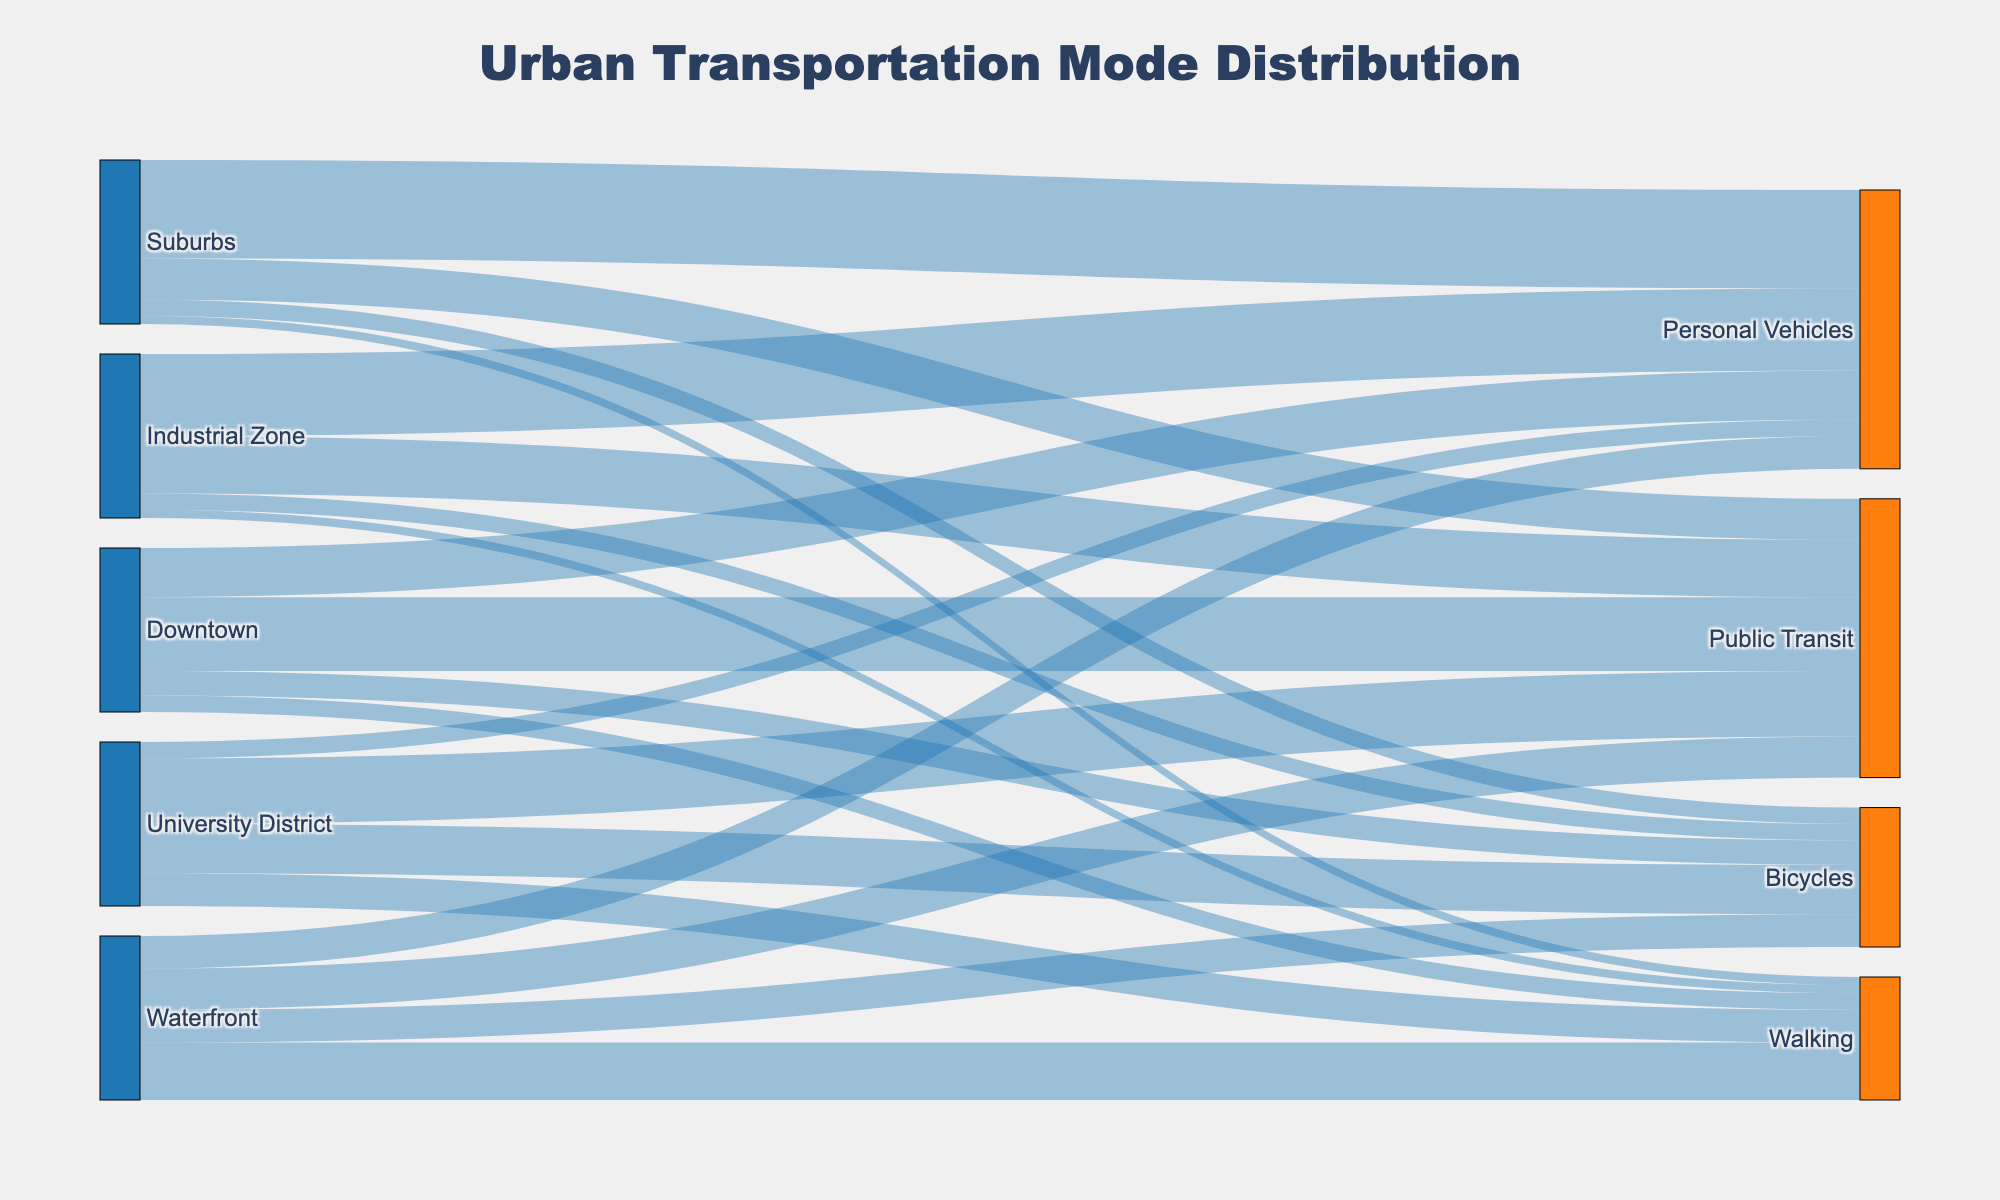What is the title of the Sankey diagram? The title is typically located at the top center of the diagram and is clearly labeled.
Answer: Urban Transportation Mode Distribution How many transportation modes are represented in the Sankey diagram? We can see the different transportation modes as the targets of the links stemming from various city zones. A quick count of the unique target labels provides the answer.
Answer: 4 Which city zone has the highest use of walking as a transportation mode? Locate the flow directed towards 'Walking' and check the originating source with the highest associated value.
Answer: Waterfront What is the total number of people using bicycles across all city zones? Sum up all the values associated with the 'Bicycles' target from different city zones. The values are 15 (Downtown) + 10 (Suburbs) + 10 (Industrial Zone) + 30 (University District) + 20 (Waterfront). 15 + 10 + 10 + 30 + 20 = 85
Answer: 85 Is Public Transit more popular in the University District compared to the Industrial Zone? Refer to the values linked to 'Public Transit' from both the University District and Industrial Zone. Compare these values directly. The University District has 40, while the Industrial Zone has 35.
Answer: Yes How many city zones have Personal Vehicles as the most used transportation mode? Identify the city zones and check the highest value among different transportation modes for each zone. Count how many zones have 'Personal Vehicles' as the mode with the highest value. This is true for Suburbs (60) and Industrial Zone (50).
Answer: 2 What percentage of Downtown's transport is made up by Public Transit? Calculate the proportion of Downtown's value directed towards Public Transit out of its total transportation values. Total for Downtown is 45 (Public Transit) + 30 (Personal Vehicles) + 15 (Bicycles) + 10 (Walking) = 100. So, (45/100) * 100 = 45%.
Answer: 45% Which zone has the lowest contribution to Public Transit? Check the values entering the 'Public Transit' target from different zones and identify the minimum. Suburbs have the smallest value of 25 compared to Downtown (45), Industrial Zone (35), University District (40), and Waterfront (25).
Answer: Suburbs Compare the total transportation values for Personal Vehicles between Suburbs and Waterfront. Which zone has more? Sum the values for 'Personal Vehicles' originating from both zones. Suburbs have 60, and Waterfront has 20. Thus, Suburbs have more.
Answer: Suburbs Which zone has the most balanced distribution across all transportation modes? A balanced distribution implies that the values across different modes are more evenly spread. Compare the values for each transportation mode within each zone.
Answer: University District 